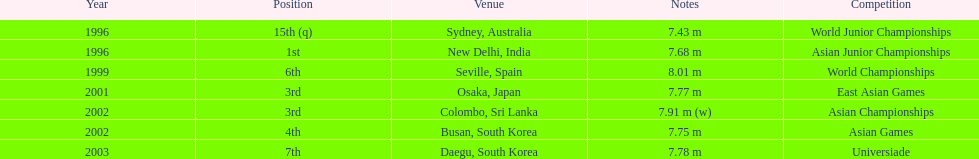In what year was the position of 3rd first achieved? 2001. 